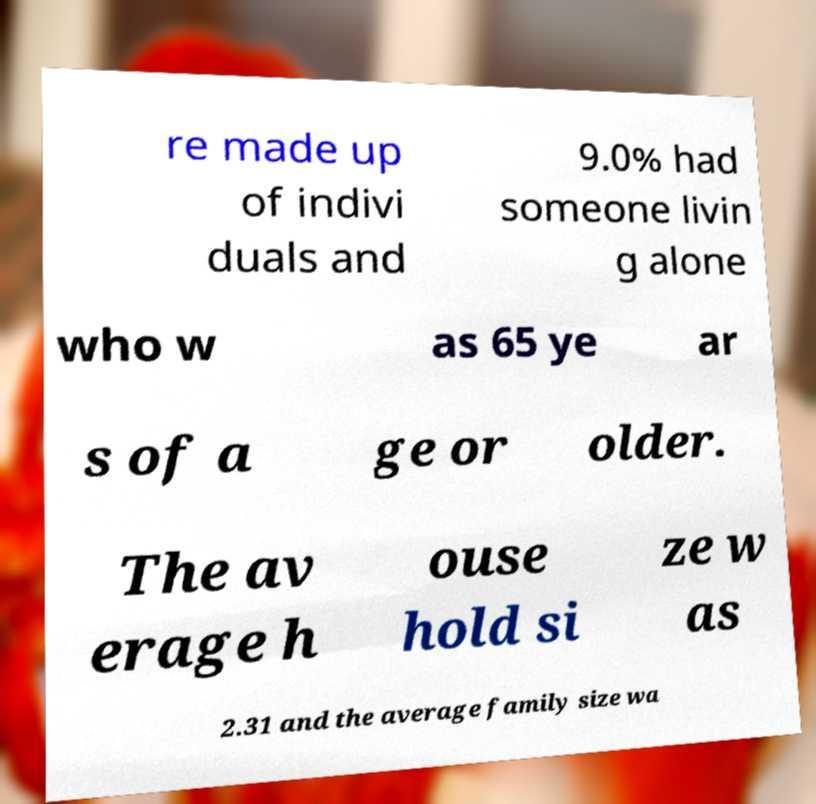Can you read and provide the text displayed in the image?This photo seems to have some interesting text. Can you extract and type it out for me? re made up of indivi duals and 9.0% had someone livin g alone who w as 65 ye ar s of a ge or older. The av erage h ouse hold si ze w as 2.31 and the average family size wa 